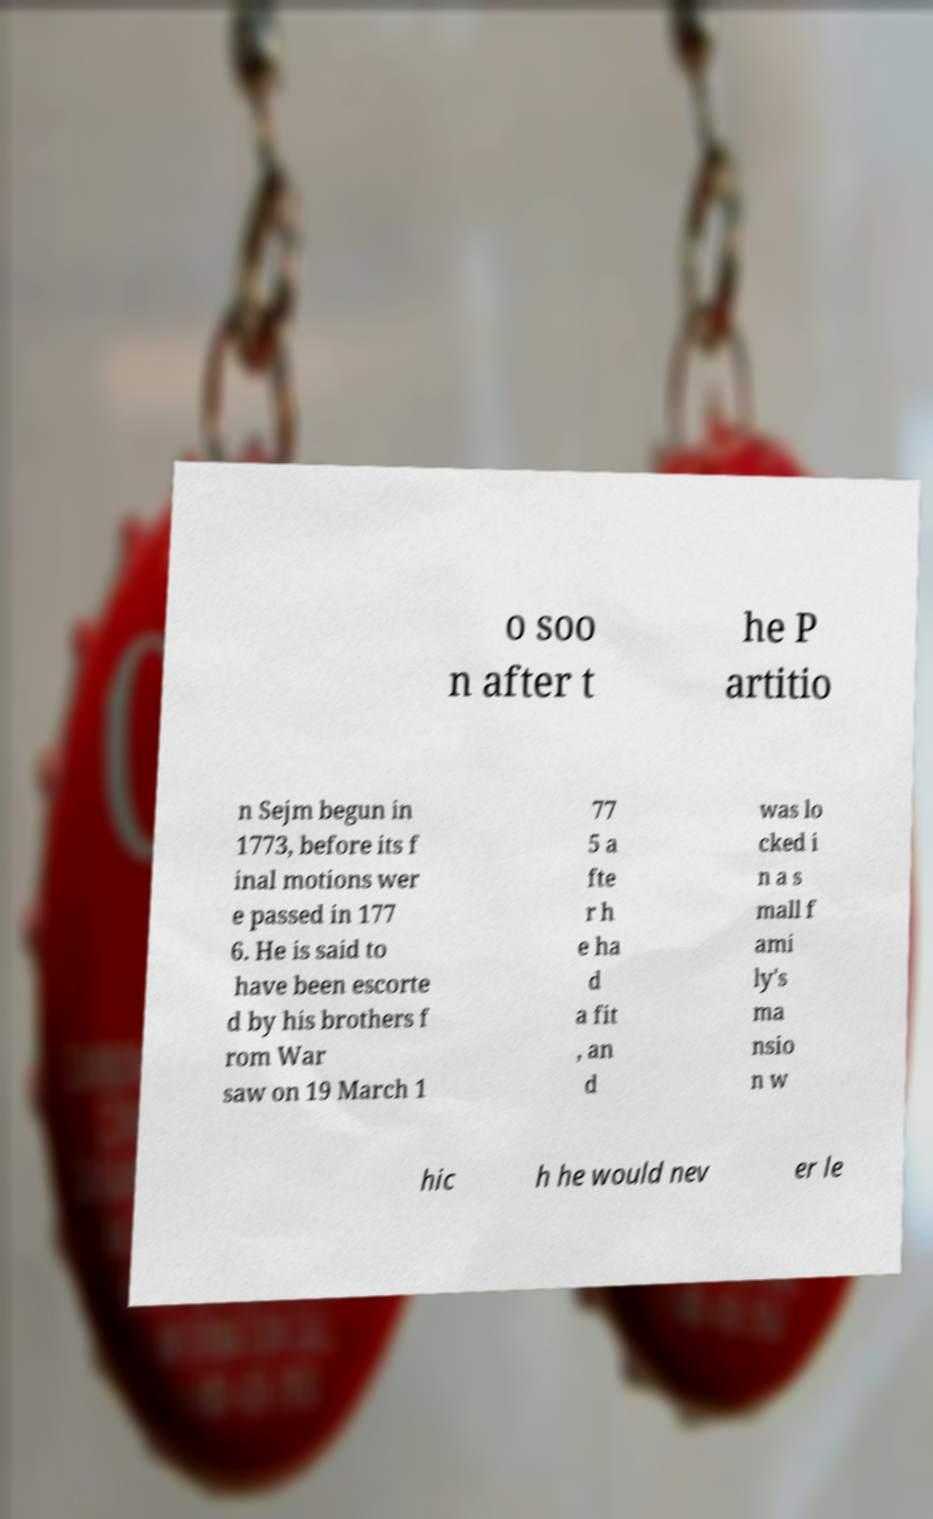What messages or text are displayed in this image? I need them in a readable, typed format. o soo n after t he P artitio n Sejm begun in 1773, before its f inal motions wer e passed in 177 6. He is said to have been escorte d by his brothers f rom War saw on 19 March 1 77 5 a fte r h e ha d a fit , an d was lo cked i n a s mall f ami ly's ma nsio n w hic h he would nev er le 